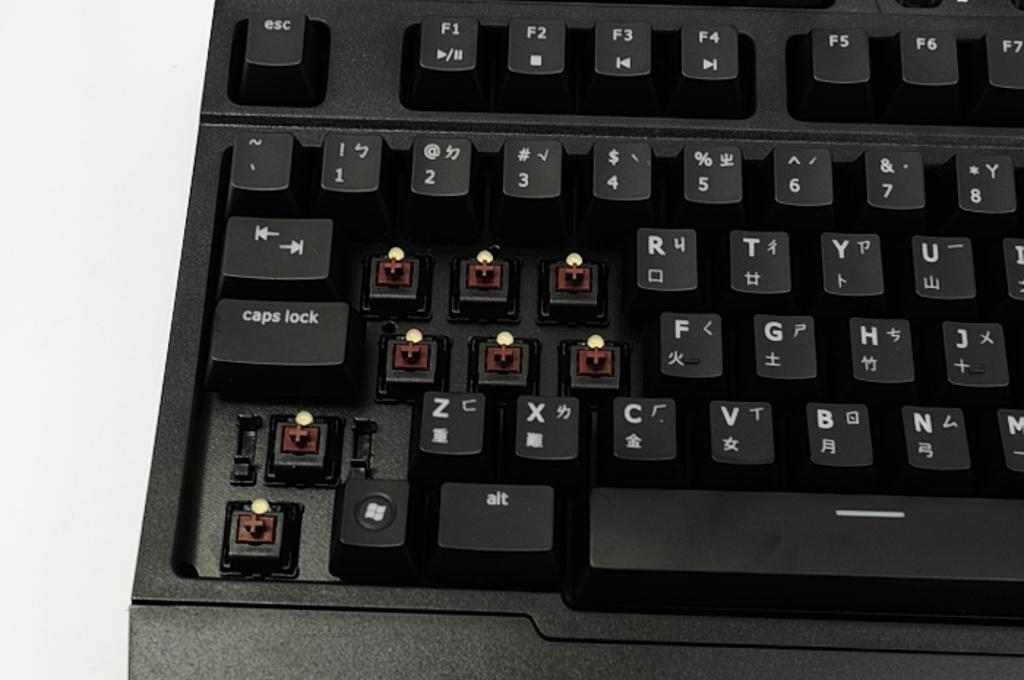<image>
Describe the image concisely. A black mechanical switch keyboard with the q,w,e,a,s,d, shift and ctrl key missing. 